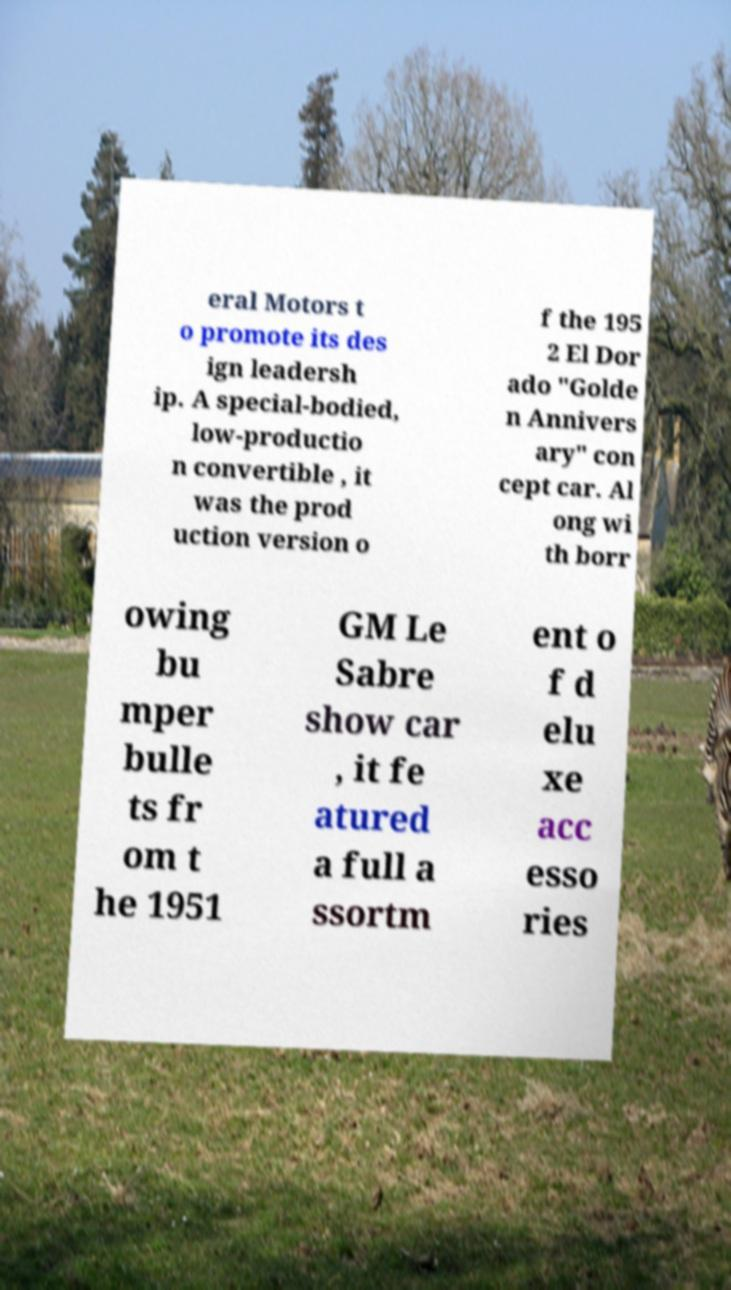There's text embedded in this image that I need extracted. Can you transcribe it verbatim? eral Motors t o promote its des ign leadersh ip. A special-bodied, low-productio n convertible , it was the prod uction version o f the 195 2 El Dor ado "Golde n Annivers ary" con cept car. Al ong wi th borr owing bu mper bulle ts fr om t he 1951 GM Le Sabre show car , it fe atured a full a ssortm ent o f d elu xe acc esso ries 